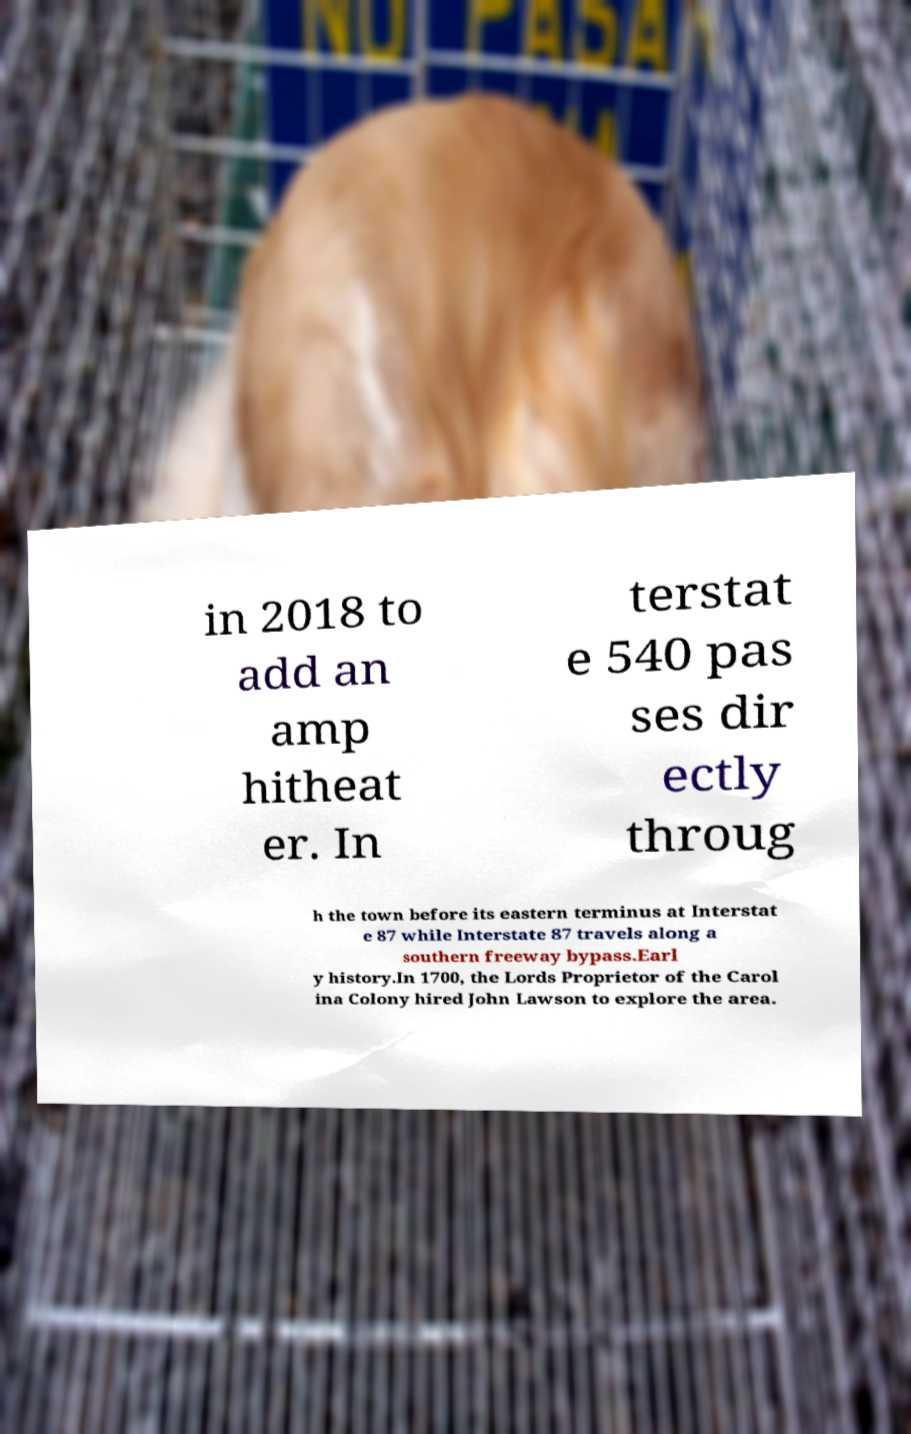Can you accurately transcribe the text from the provided image for me? in 2018 to add an amp hitheat er. In terstat e 540 pas ses dir ectly throug h the town before its eastern terminus at Interstat e 87 while Interstate 87 travels along a southern freeway bypass.Earl y history.In 1700, the Lords Proprietor of the Carol ina Colony hired John Lawson to explore the area. 